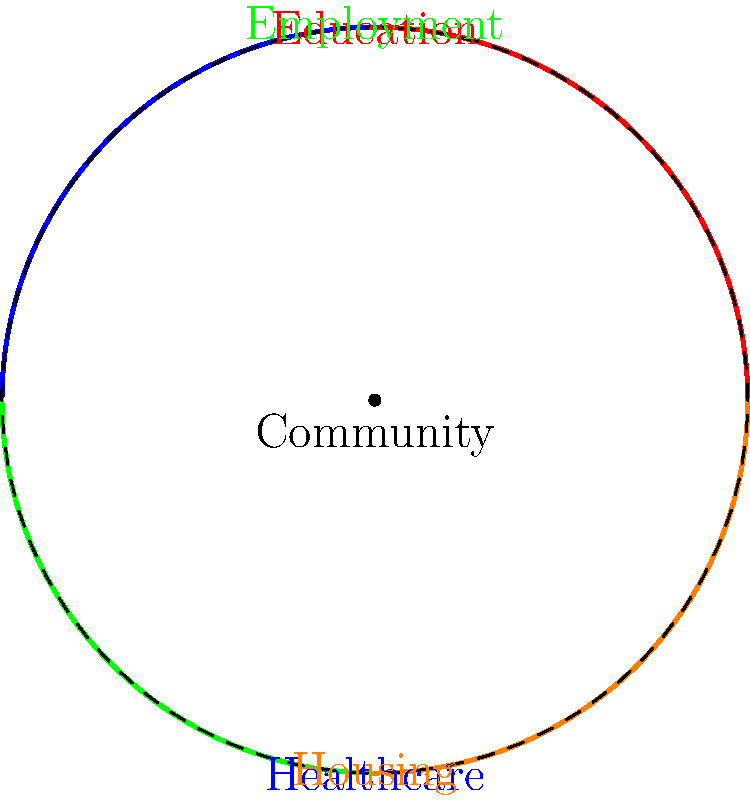Consider the diagram representing interconnected social issues in a community. The fundamental group of this space is isomorphic to which group, and what does this reveal about the nature of social challenges? To determine the fundamental group of this space and its implications for social challenges, let's follow these steps:

1) Observe the diagram: It shows four arcs representing different social issues (Education, Healthcare, Employment, and Housing) connected at a central point (Community).

2) Topological analysis:
   - The space is essentially a circle divided into four segments.
   - All four arcs are connected at a single point, forming a loop.

3) Fundamental group determination:
   - The fundamental group of a circle is isomorphic to the integers under addition, denoted as $\mathbb{Z}$.
   - This is because we can wind around the circle any number of times in either direction.

4) Interpretation for social challenges:
   - The isomorphism to $\mathbb{Z}$ indicates that social issues are cyclical and interconnected.
   - Each complete loop ($n \in \mathbb{Z}$) represents a full cycle through all social issues.
   - Positive integers represent progress, while negative integers could represent regression.

5) Implications:
   - The cyclical nature suggests that addressing one issue affects others.
   - The infinite nature of $\mathbb{Z}$ implies that social work is an ongoing process.
   - The connectedness shows that a holistic approach is necessary in addressing community issues.

Therefore, the fundamental group being isomorphic to $\mathbb{Z}$ reveals that social challenges are inherently interconnected, cyclical, and require continuous, comprehensive efforts to address.
Answer: $\mathbb{Z}$, revealing cyclical and interconnected nature of social issues 